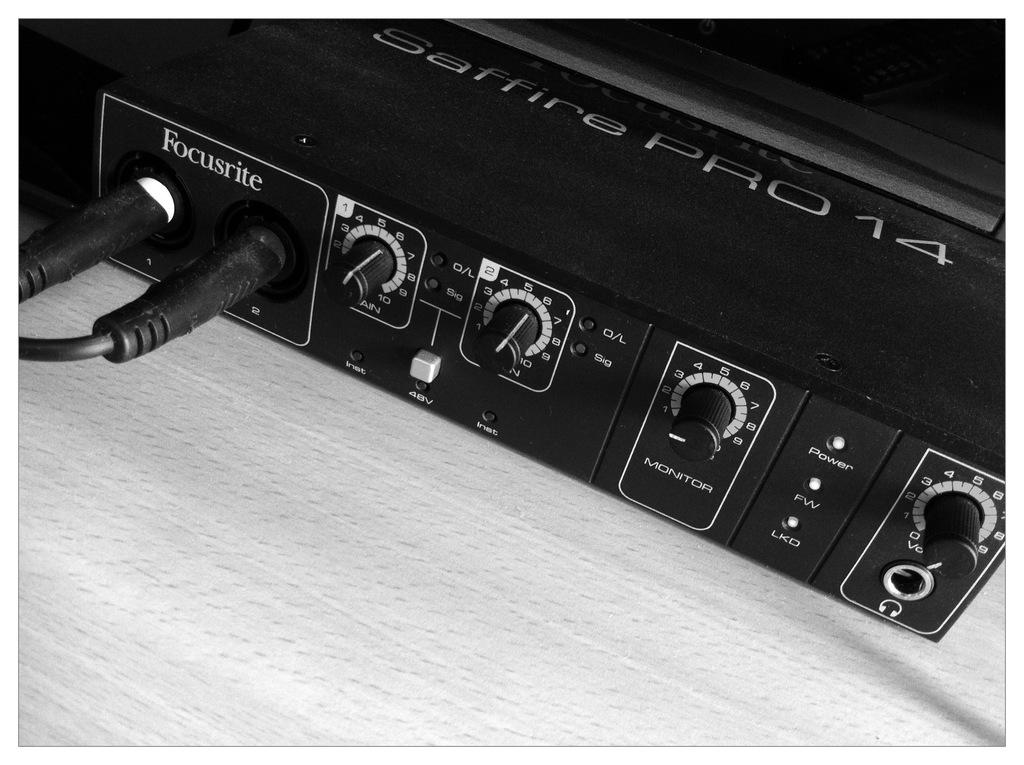What type of furniture is present in the image? There is a table in the image. What kind of object can be seen on or near the table? There is an electronic gadget in the image. Is there any connection between the electronic gadget and another object in the image? Yes, there is a cable in the image. What type of advertisement can be seen on the property in the image? There is no property or advertisement present in the image. What type of bottle is visible on the table in the image? There is no bottle present in the image. 